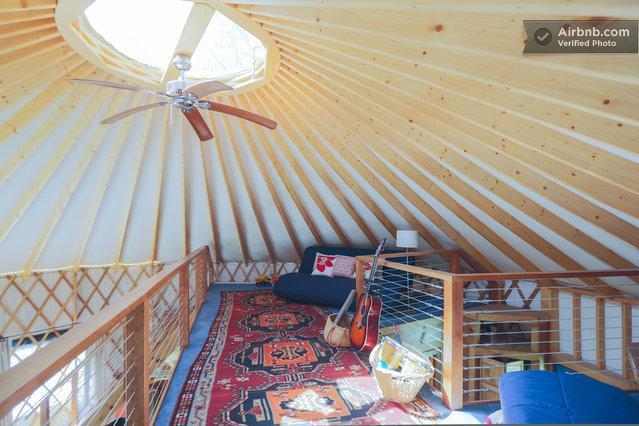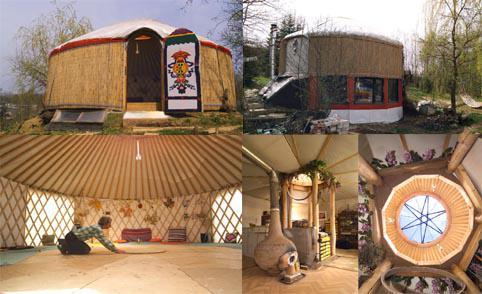The first image is the image on the left, the second image is the image on the right. For the images shown, is this caption "One of the images contains the exterior of a yurt." true? Answer yes or no. Yes. The first image is the image on the left, the second image is the image on the right. For the images displayed, is the sentence "The left image features at least one plant with long green leaves near something resembling a table." factually correct? Answer yes or no. No. 